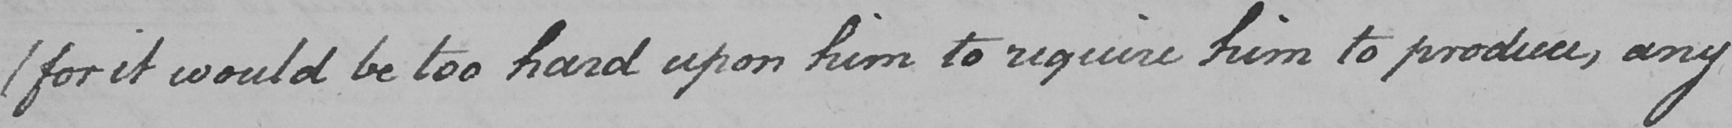What is written in this line of handwriting? ( for it would be too hard upon him to require him to produce , any 